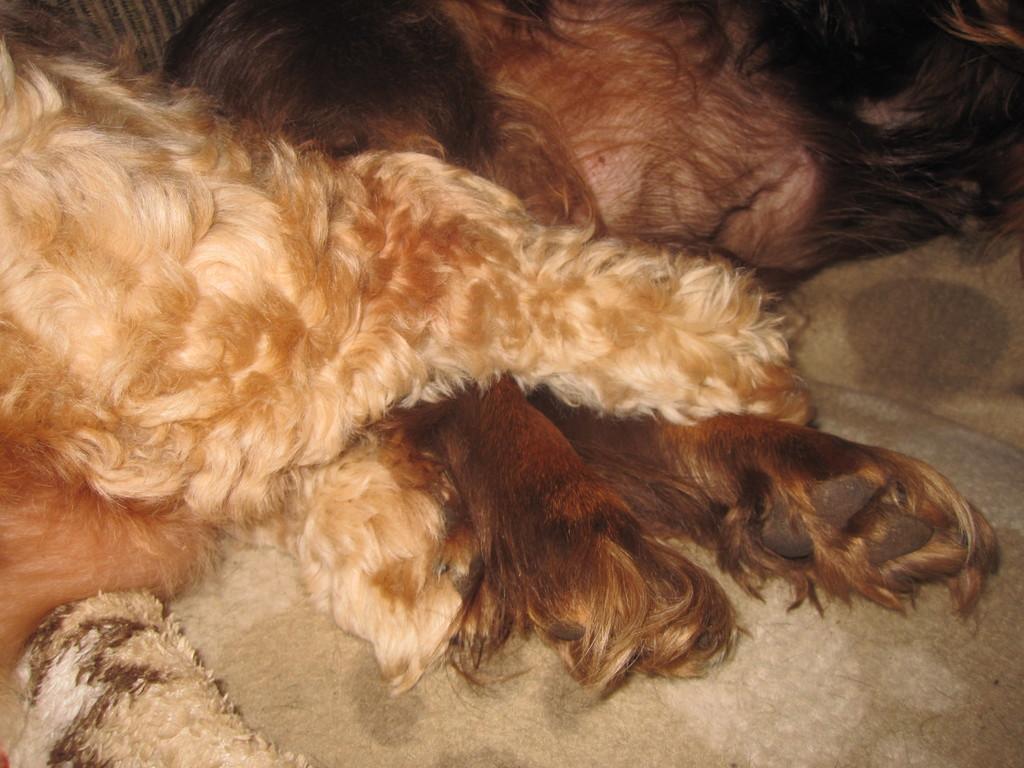How would you summarize this image in a sentence or two? In this image we can see an animal lying on the floor. 